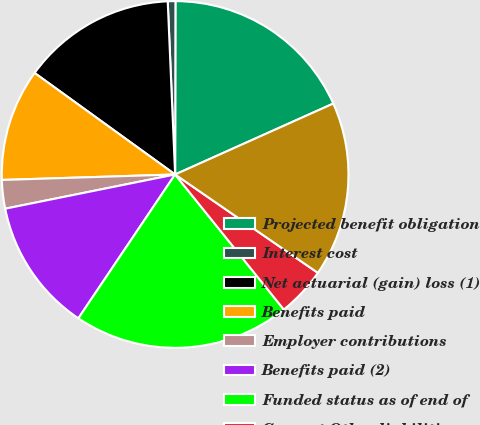Convert chart. <chart><loc_0><loc_0><loc_500><loc_500><pie_chart><fcel>Projected benefit obligation<fcel>Interest cost<fcel>Net actuarial (gain) loss (1)<fcel>Benefits paid<fcel>Employer contributions<fcel>Benefits paid (2)<fcel>Funded status as of end of<fcel>Current Other liabilities<fcel>Benefit obligations<nl><fcel>18.26%<fcel>0.71%<fcel>14.36%<fcel>10.46%<fcel>2.66%<fcel>12.41%<fcel>20.21%<fcel>4.61%<fcel>16.31%<nl></chart> 